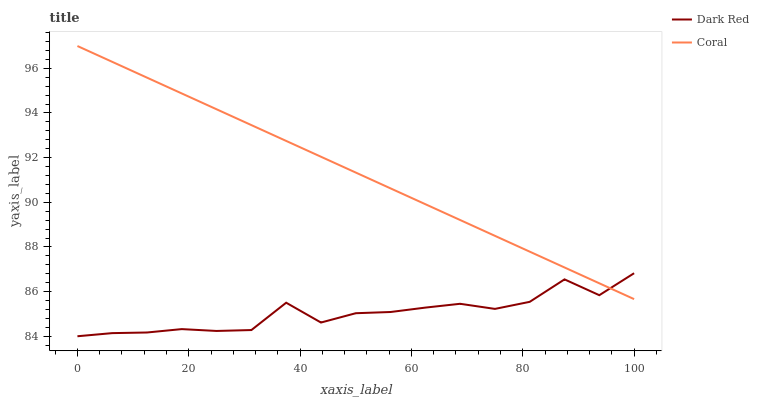Does Dark Red have the minimum area under the curve?
Answer yes or no. Yes. Does Coral have the maximum area under the curve?
Answer yes or no. Yes. Does Coral have the minimum area under the curve?
Answer yes or no. No. Is Coral the smoothest?
Answer yes or no. Yes. Is Dark Red the roughest?
Answer yes or no. Yes. Is Coral the roughest?
Answer yes or no. No. Does Dark Red have the lowest value?
Answer yes or no. Yes. Does Coral have the lowest value?
Answer yes or no. No. Does Coral have the highest value?
Answer yes or no. Yes. Does Dark Red intersect Coral?
Answer yes or no. Yes. Is Dark Red less than Coral?
Answer yes or no. No. Is Dark Red greater than Coral?
Answer yes or no. No. 